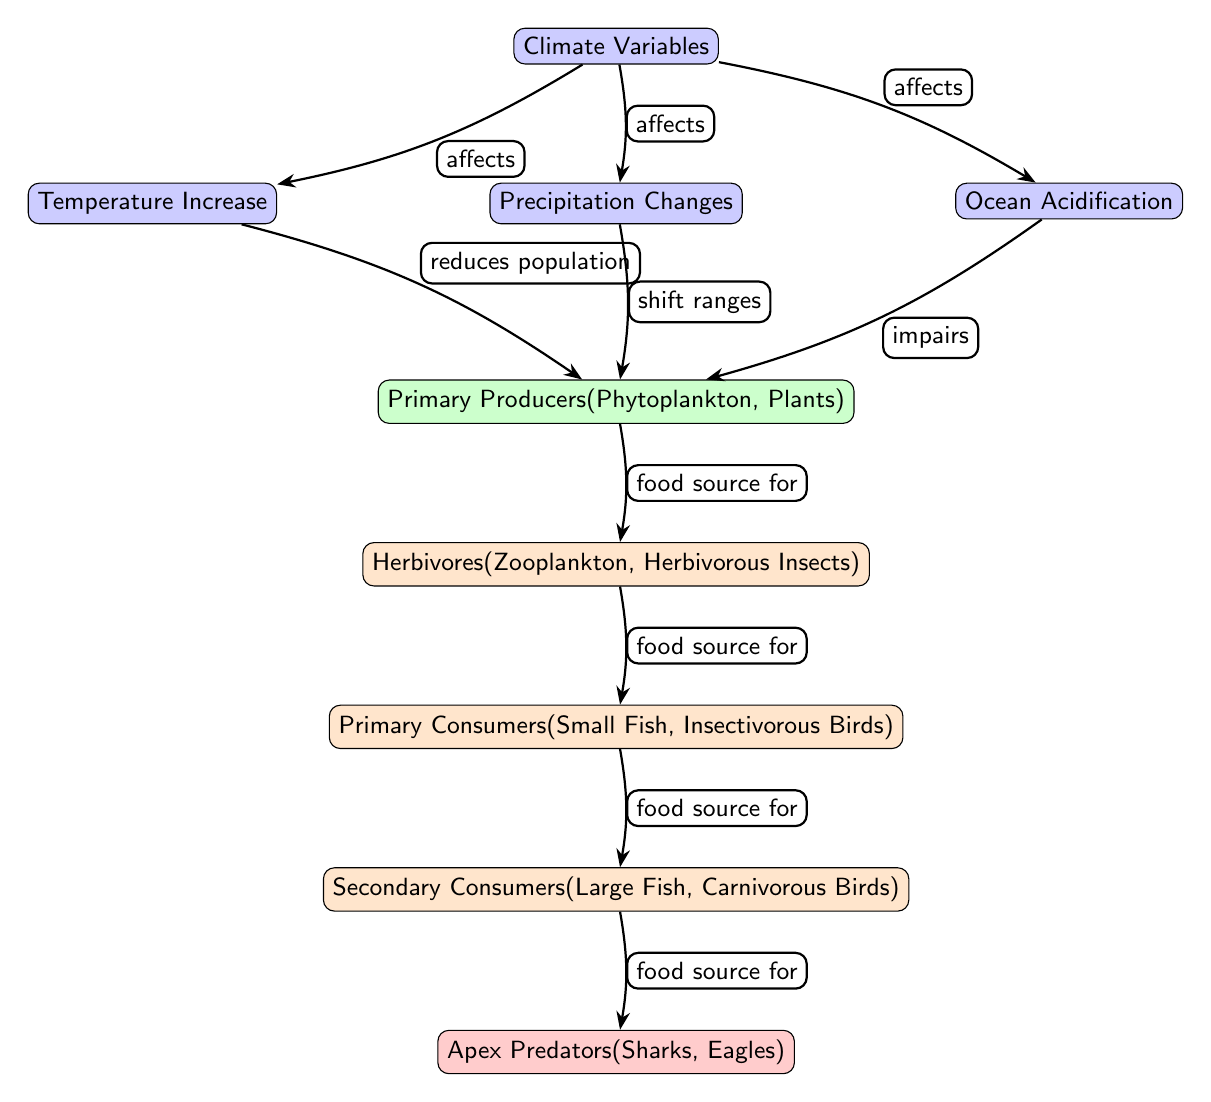What are the climate variables represented in the diagram? The diagram lists three climate variables: Temperature Increase, Precipitation Changes, and Ocean Acidification. These are located below the node labeled "Climate Variables."
Answer: Temperature Increase, Precipitation Changes, Ocean Acidification How many nodes represent consumers in the food chain? There are three consumer nodes in the food chain, which include Herbivores, Primary Consumers, and Secondary Consumers. These nodes are located beneath the Primary Producers.
Answer: 3 What effect does temperature increase have on primary producers? The diagram shows that temperature increase "reduces population" of primary producers, indicating a negative impact. This relationship is denoted by an edge from Temperature Increase to Primary Producers.
Answer: reduces population Which node is directly affected by ocean acidification? Ocean Acidification directly "impairs" Primary Producers, as indicated by the edge from the Ocean Acidification node to the Primary Producers node.
Answer: Primary Producers How do precipitation changes affect primary producers? Precipitation Changes "shift ranges" of Primary Producers, according to the connection shown in the diagram. This means that changes in precipitation affect where Primary Producers can thrive.
Answer: shift ranges Which type of consumers directly feeds on primary consumers? The diagram specifies that Secondary Consumers feed on Primary Consumers, shown by the edge going from Primary Consumers to Secondary Consumers.
Answer: Secondary Consumers What is the relationship between primary producers and herbivores? Primary Producers serve as a "food source for" Herbivores, an arrow pointing from Primary Producers to Herbivores indicates the direct food chain relationship.
Answer: food source for Identify one apex predator mentioned in the diagram. The diagram lists Sharks and Eagles as examples of apex predators, located at the bottom of the food chain section.
Answer: Sharks, Eagles 